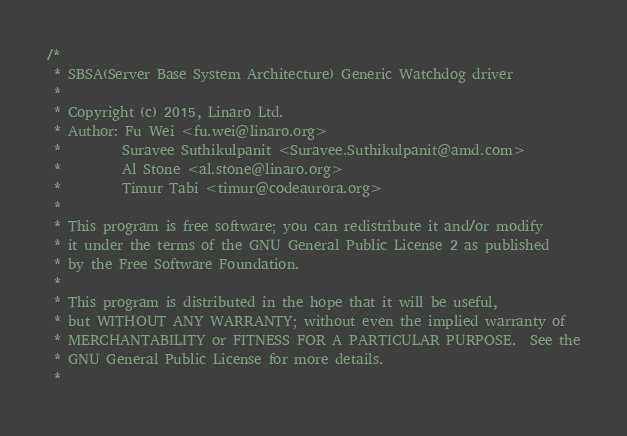Convert code to text. <code><loc_0><loc_0><loc_500><loc_500><_C_>/*
 * SBSA(Server Base System Architecture) Generic Watchdog driver
 *
 * Copyright (c) 2015, Linaro Ltd.
 * Author: Fu Wei <fu.wei@linaro.org>
 *         Suravee Suthikulpanit <Suravee.Suthikulpanit@amd.com>
 *         Al Stone <al.stone@linaro.org>
 *         Timur Tabi <timur@codeaurora.org>
 *
 * This program is free software; you can redistribute it and/or modify
 * it under the terms of the GNU General Public License 2 as published
 * by the Free Software Foundation.
 *
 * This program is distributed in the hope that it will be useful,
 * but WITHOUT ANY WARRANTY; without even the implied warranty of
 * MERCHANTABILITY or FITNESS FOR A PARTICULAR PURPOSE.  See the
 * GNU General Public License for more details.
 *</code> 